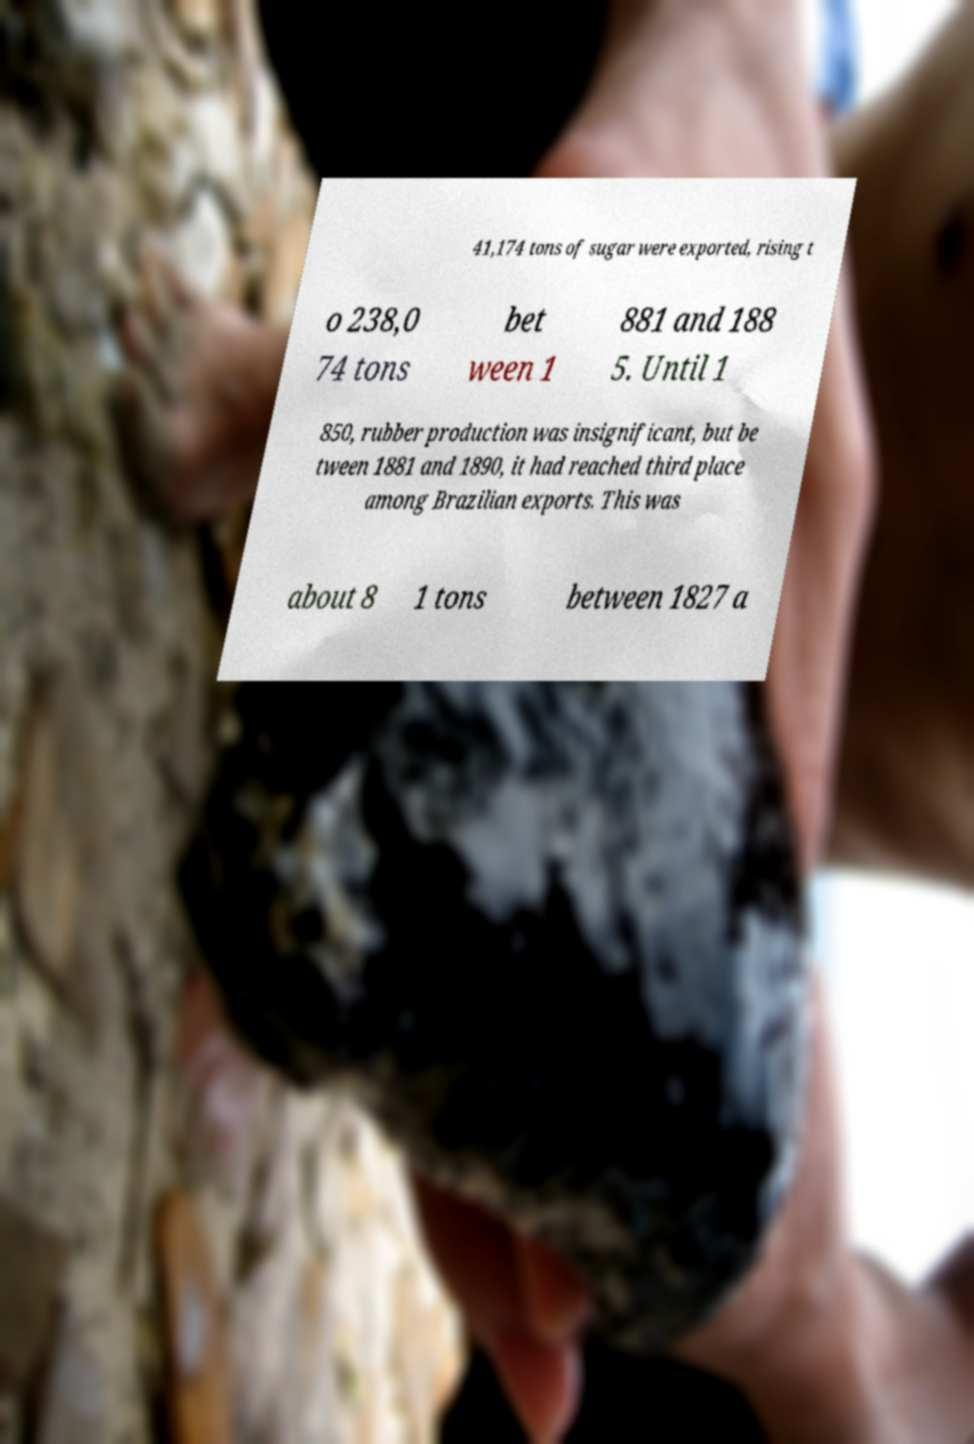For documentation purposes, I need the text within this image transcribed. Could you provide that? 41,174 tons of sugar were exported, rising t o 238,0 74 tons bet ween 1 881 and 188 5. Until 1 850, rubber production was insignificant, but be tween 1881 and 1890, it had reached third place among Brazilian exports. This was about 8 1 tons between 1827 a 